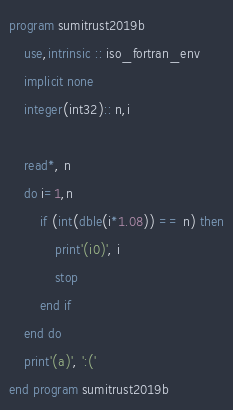Convert code to text. <code><loc_0><loc_0><loc_500><loc_500><_FORTRAN_>program sumitrust2019b
    use,intrinsic :: iso_fortran_env
    implicit none
    integer(int32):: n,i

    read*, n
    do i=1,n
        if (int(dble(i*1.08)) == n) then
            print'(i0)', i
            stop
        end if
    end do
    print'(a)', ':('
end program sumitrust2019b</code> 